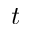<formula> <loc_0><loc_0><loc_500><loc_500>t</formula> 